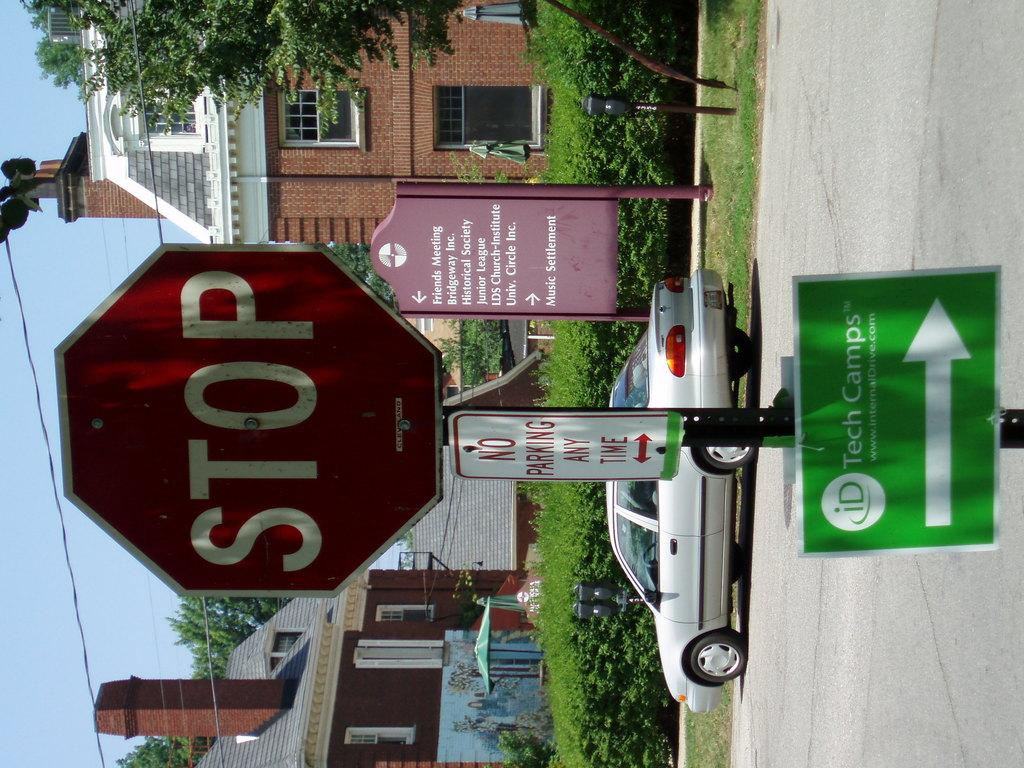Provide a one-sentence caption for the provided image. A stop sign with a sign for tech camps under it. 